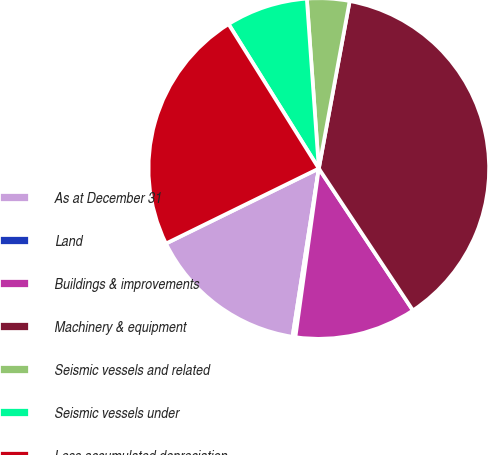Convert chart to OTSL. <chart><loc_0><loc_0><loc_500><loc_500><pie_chart><fcel>As at December 31<fcel>Land<fcel>Buildings & improvements<fcel>Machinery & equipment<fcel>Seismic vessels and related<fcel>Seismic vessels under<fcel>Less accumulated depreciation<nl><fcel>15.27%<fcel>0.27%<fcel>11.52%<fcel>37.78%<fcel>4.02%<fcel>7.77%<fcel>23.37%<nl></chart> 